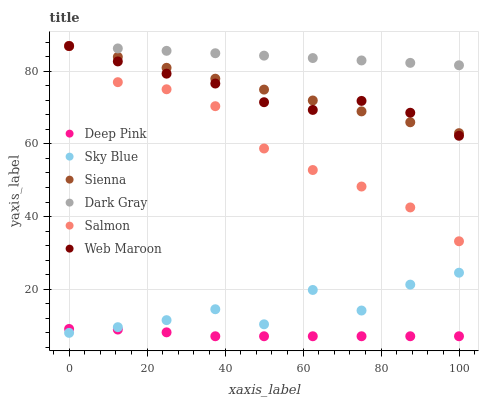Does Deep Pink have the minimum area under the curve?
Answer yes or no. Yes. Does Dark Gray have the maximum area under the curve?
Answer yes or no. Yes. Does Salmon have the minimum area under the curve?
Answer yes or no. No. Does Salmon have the maximum area under the curve?
Answer yes or no. No. Is Dark Gray the smoothest?
Answer yes or no. Yes. Is Sky Blue the roughest?
Answer yes or no. Yes. Is Deep Pink the smoothest?
Answer yes or no. No. Is Deep Pink the roughest?
Answer yes or no. No. Does Deep Pink have the lowest value?
Answer yes or no. Yes. Does Salmon have the lowest value?
Answer yes or no. No. Does Sienna have the highest value?
Answer yes or no. Yes. Does Deep Pink have the highest value?
Answer yes or no. No. Is Deep Pink less than Web Maroon?
Answer yes or no. Yes. Is Web Maroon greater than Deep Pink?
Answer yes or no. Yes. Does Dark Gray intersect Web Maroon?
Answer yes or no. Yes. Is Dark Gray less than Web Maroon?
Answer yes or no. No. Is Dark Gray greater than Web Maroon?
Answer yes or no. No. Does Deep Pink intersect Web Maroon?
Answer yes or no. No. 